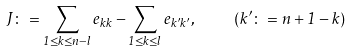Convert formula to latex. <formula><loc_0><loc_0><loc_500><loc_500>J \colon = \sum _ { 1 \leq k \leq n - l } e _ { k k } - \sum _ { 1 \leq k \leq l } e _ { k ^ { \prime } k ^ { \prime } } , \quad ( k ^ { \prime } \colon = n + 1 - k )</formula> 